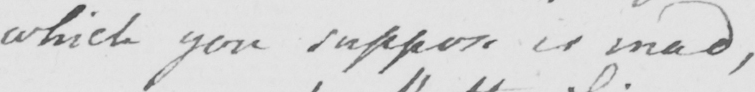What is written in this line of handwriting? which you suppose is mad , 